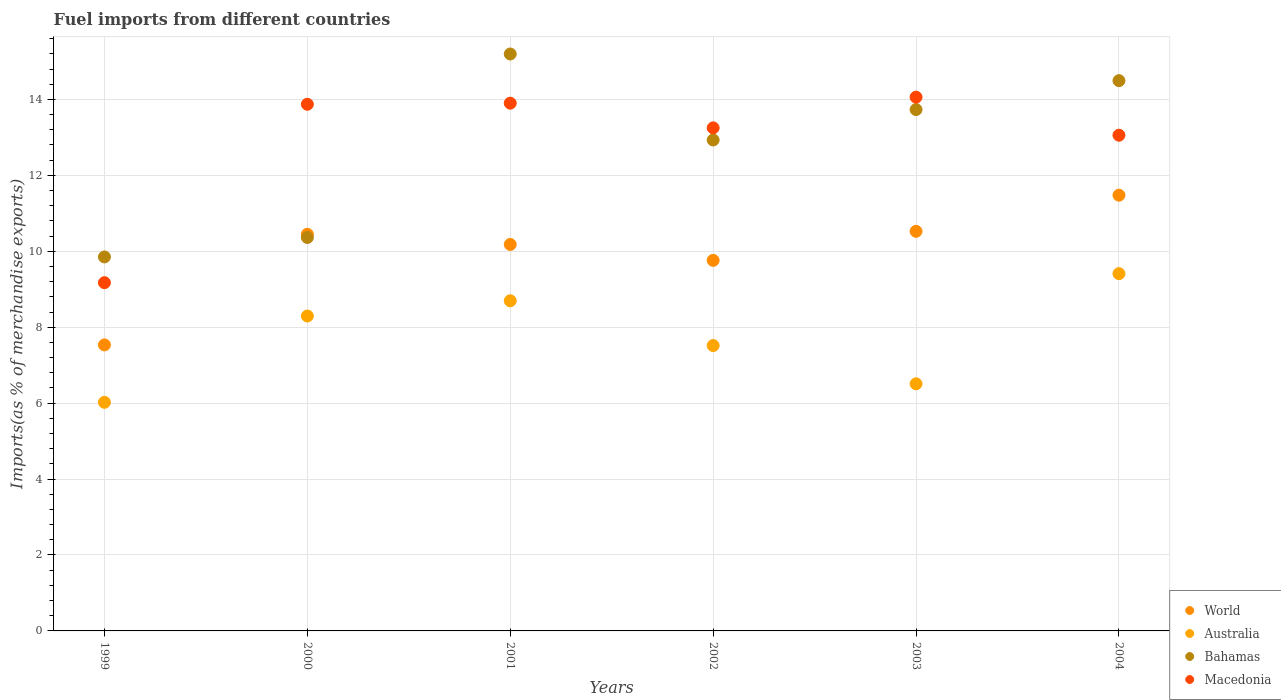How many different coloured dotlines are there?
Provide a succinct answer. 4. What is the percentage of imports to different countries in World in 2002?
Your answer should be compact. 9.76. Across all years, what is the maximum percentage of imports to different countries in Macedonia?
Make the answer very short. 14.06. Across all years, what is the minimum percentage of imports to different countries in World?
Offer a terse response. 7.53. What is the total percentage of imports to different countries in World in the graph?
Offer a very short reply. 59.93. What is the difference between the percentage of imports to different countries in Australia in 2002 and that in 2004?
Your answer should be very brief. -1.89. What is the difference between the percentage of imports to different countries in Bahamas in 2002 and the percentage of imports to different countries in Macedonia in 2003?
Offer a very short reply. -1.13. What is the average percentage of imports to different countries in Macedonia per year?
Ensure brevity in your answer.  12.89. In the year 2001, what is the difference between the percentage of imports to different countries in Australia and percentage of imports to different countries in Bahamas?
Ensure brevity in your answer.  -6.5. In how many years, is the percentage of imports to different countries in Macedonia greater than 1.6 %?
Your response must be concise. 6. What is the ratio of the percentage of imports to different countries in Australia in 1999 to that in 2002?
Provide a succinct answer. 0.8. Is the percentage of imports to different countries in Australia in 2001 less than that in 2003?
Give a very brief answer. No. Is the difference between the percentage of imports to different countries in Australia in 2003 and 2004 greater than the difference between the percentage of imports to different countries in Bahamas in 2003 and 2004?
Ensure brevity in your answer.  No. What is the difference between the highest and the second highest percentage of imports to different countries in World?
Offer a very short reply. 0.95. What is the difference between the highest and the lowest percentage of imports to different countries in Bahamas?
Offer a very short reply. 5.35. Does the percentage of imports to different countries in Bahamas monotonically increase over the years?
Provide a short and direct response. No. How many dotlines are there?
Offer a very short reply. 4. How many years are there in the graph?
Offer a terse response. 6. Are the values on the major ticks of Y-axis written in scientific E-notation?
Keep it short and to the point. No. Where does the legend appear in the graph?
Your answer should be compact. Bottom right. How many legend labels are there?
Provide a succinct answer. 4. How are the legend labels stacked?
Make the answer very short. Vertical. What is the title of the graph?
Ensure brevity in your answer.  Fuel imports from different countries. Does "Arab World" appear as one of the legend labels in the graph?
Make the answer very short. No. What is the label or title of the Y-axis?
Give a very brief answer. Imports(as % of merchandise exports). What is the Imports(as % of merchandise exports) in World in 1999?
Your answer should be very brief. 7.53. What is the Imports(as % of merchandise exports) in Australia in 1999?
Keep it short and to the point. 6.02. What is the Imports(as % of merchandise exports) of Bahamas in 1999?
Make the answer very short. 9.85. What is the Imports(as % of merchandise exports) of Macedonia in 1999?
Your response must be concise. 9.17. What is the Imports(as % of merchandise exports) of World in 2000?
Offer a very short reply. 10.45. What is the Imports(as % of merchandise exports) in Australia in 2000?
Offer a very short reply. 8.29. What is the Imports(as % of merchandise exports) in Bahamas in 2000?
Make the answer very short. 10.36. What is the Imports(as % of merchandise exports) of Macedonia in 2000?
Your answer should be compact. 13.87. What is the Imports(as % of merchandise exports) in World in 2001?
Provide a succinct answer. 10.18. What is the Imports(as % of merchandise exports) of Australia in 2001?
Provide a short and direct response. 8.7. What is the Imports(as % of merchandise exports) of Bahamas in 2001?
Your answer should be compact. 15.2. What is the Imports(as % of merchandise exports) in Macedonia in 2001?
Keep it short and to the point. 13.9. What is the Imports(as % of merchandise exports) of World in 2002?
Provide a short and direct response. 9.76. What is the Imports(as % of merchandise exports) of Australia in 2002?
Keep it short and to the point. 7.52. What is the Imports(as % of merchandise exports) in Bahamas in 2002?
Offer a terse response. 12.93. What is the Imports(as % of merchandise exports) of Macedonia in 2002?
Your answer should be compact. 13.25. What is the Imports(as % of merchandise exports) of World in 2003?
Ensure brevity in your answer.  10.53. What is the Imports(as % of merchandise exports) in Australia in 2003?
Offer a very short reply. 6.51. What is the Imports(as % of merchandise exports) of Bahamas in 2003?
Offer a very short reply. 13.73. What is the Imports(as % of merchandise exports) of Macedonia in 2003?
Offer a terse response. 14.06. What is the Imports(as % of merchandise exports) of World in 2004?
Provide a succinct answer. 11.48. What is the Imports(as % of merchandise exports) in Australia in 2004?
Give a very brief answer. 9.41. What is the Imports(as % of merchandise exports) in Bahamas in 2004?
Your answer should be very brief. 14.49. What is the Imports(as % of merchandise exports) of Macedonia in 2004?
Keep it short and to the point. 13.06. Across all years, what is the maximum Imports(as % of merchandise exports) of World?
Give a very brief answer. 11.48. Across all years, what is the maximum Imports(as % of merchandise exports) in Australia?
Offer a terse response. 9.41. Across all years, what is the maximum Imports(as % of merchandise exports) in Bahamas?
Offer a terse response. 15.2. Across all years, what is the maximum Imports(as % of merchandise exports) in Macedonia?
Your answer should be very brief. 14.06. Across all years, what is the minimum Imports(as % of merchandise exports) of World?
Your answer should be very brief. 7.53. Across all years, what is the minimum Imports(as % of merchandise exports) of Australia?
Give a very brief answer. 6.02. Across all years, what is the minimum Imports(as % of merchandise exports) in Bahamas?
Offer a very short reply. 9.85. Across all years, what is the minimum Imports(as % of merchandise exports) of Macedonia?
Offer a very short reply. 9.17. What is the total Imports(as % of merchandise exports) of World in the graph?
Make the answer very short. 59.93. What is the total Imports(as % of merchandise exports) in Australia in the graph?
Your response must be concise. 46.45. What is the total Imports(as % of merchandise exports) of Bahamas in the graph?
Give a very brief answer. 76.57. What is the total Imports(as % of merchandise exports) of Macedonia in the graph?
Your answer should be very brief. 77.31. What is the difference between the Imports(as % of merchandise exports) in World in 1999 and that in 2000?
Ensure brevity in your answer.  -2.91. What is the difference between the Imports(as % of merchandise exports) in Australia in 1999 and that in 2000?
Provide a short and direct response. -2.27. What is the difference between the Imports(as % of merchandise exports) in Bahamas in 1999 and that in 2000?
Ensure brevity in your answer.  -0.51. What is the difference between the Imports(as % of merchandise exports) in Macedonia in 1999 and that in 2000?
Give a very brief answer. -4.7. What is the difference between the Imports(as % of merchandise exports) of World in 1999 and that in 2001?
Give a very brief answer. -2.65. What is the difference between the Imports(as % of merchandise exports) of Australia in 1999 and that in 2001?
Ensure brevity in your answer.  -2.67. What is the difference between the Imports(as % of merchandise exports) of Bahamas in 1999 and that in 2001?
Your response must be concise. -5.35. What is the difference between the Imports(as % of merchandise exports) in Macedonia in 1999 and that in 2001?
Give a very brief answer. -4.73. What is the difference between the Imports(as % of merchandise exports) of World in 1999 and that in 2002?
Offer a terse response. -2.23. What is the difference between the Imports(as % of merchandise exports) in Australia in 1999 and that in 2002?
Your answer should be very brief. -1.49. What is the difference between the Imports(as % of merchandise exports) in Bahamas in 1999 and that in 2002?
Your answer should be compact. -3.08. What is the difference between the Imports(as % of merchandise exports) in Macedonia in 1999 and that in 2002?
Your answer should be compact. -4.08. What is the difference between the Imports(as % of merchandise exports) in World in 1999 and that in 2003?
Provide a succinct answer. -2.99. What is the difference between the Imports(as % of merchandise exports) of Australia in 1999 and that in 2003?
Provide a short and direct response. -0.49. What is the difference between the Imports(as % of merchandise exports) in Bahamas in 1999 and that in 2003?
Your answer should be compact. -3.88. What is the difference between the Imports(as % of merchandise exports) of Macedonia in 1999 and that in 2003?
Offer a very short reply. -4.89. What is the difference between the Imports(as % of merchandise exports) of World in 1999 and that in 2004?
Ensure brevity in your answer.  -3.94. What is the difference between the Imports(as % of merchandise exports) in Australia in 1999 and that in 2004?
Offer a very short reply. -3.39. What is the difference between the Imports(as % of merchandise exports) of Bahamas in 1999 and that in 2004?
Provide a short and direct response. -4.64. What is the difference between the Imports(as % of merchandise exports) in Macedonia in 1999 and that in 2004?
Give a very brief answer. -3.88. What is the difference between the Imports(as % of merchandise exports) in World in 2000 and that in 2001?
Make the answer very short. 0.27. What is the difference between the Imports(as % of merchandise exports) of Australia in 2000 and that in 2001?
Your answer should be very brief. -0.4. What is the difference between the Imports(as % of merchandise exports) of Bahamas in 2000 and that in 2001?
Your response must be concise. -4.83. What is the difference between the Imports(as % of merchandise exports) of Macedonia in 2000 and that in 2001?
Make the answer very short. -0.03. What is the difference between the Imports(as % of merchandise exports) in World in 2000 and that in 2002?
Provide a short and direct response. 0.69. What is the difference between the Imports(as % of merchandise exports) in Australia in 2000 and that in 2002?
Offer a terse response. 0.78. What is the difference between the Imports(as % of merchandise exports) in Bahamas in 2000 and that in 2002?
Ensure brevity in your answer.  -2.57. What is the difference between the Imports(as % of merchandise exports) in Macedonia in 2000 and that in 2002?
Ensure brevity in your answer.  0.62. What is the difference between the Imports(as % of merchandise exports) in World in 2000 and that in 2003?
Give a very brief answer. -0.08. What is the difference between the Imports(as % of merchandise exports) of Australia in 2000 and that in 2003?
Keep it short and to the point. 1.79. What is the difference between the Imports(as % of merchandise exports) of Bahamas in 2000 and that in 2003?
Make the answer very short. -3.37. What is the difference between the Imports(as % of merchandise exports) of Macedonia in 2000 and that in 2003?
Give a very brief answer. -0.19. What is the difference between the Imports(as % of merchandise exports) of World in 2000 and that in 2004?
Offer a very short reply. -1.03. What is the difference between the Imports(as % of merchandise exports) in Australia in 2000 and that in 2004?
Give a very brief answer. -1.12. What is the difference between the Imports(as % of merchandise exports) in Bahamas in 2000 and that in 2004?
Ensure brevity in your answer.  -4.13. What is the difference between the Imports(as % of merchandise exports) of Macedonia in 2000 and that in 2004?
Your answer should be compact. 0.81. What is the difference between the Imports(as % of merchandise exports) of World in 2001 and that in 2002?
Keep it short and to the point. 0.42. What is the difference between the Imports(as % of merchandise exports) of Australia in 2001 and that in 2002?
Provide a succinct answer. 1.18. What is the difference between the Imports(as % of merchandise exports) of Bahamas in 2001 and that in 2002?
Your answer should be very brief. 2.27. What is the difference between the Imports(as % of merchandise exports) in Macedonia in 2001 and that in 2002?
Your answer should be very brief. 0.65. What is the difference between the Imports(as % of merchandise exports) in World in 2001 and that in 2003?
Your answer should be very brief. -0.35. What is the difference between the Imports(as % of merchandise exports) of Australia in 2001 and that in 2003?
Your answer should be compact. 2.19. What is the difference between the Imports(as % of merchandise exports) of Bahamas in 2001 and that in 2003?
Your answer should be very brief. 1.46. What is the difference between the Imports(as % of merchandise exports) in Macedonia in 2001 and that in 2003?
Ensure brevity in your answer.  -0.16. What is the difference between the Imports(as % of merchandise exports) in World in 2001 and that in 2004?
Offer a very short reply. -1.3. What is the difference between the Imports(as % of merchandise exports) in Australia in 2001 and that in 2004?
Give a very brief answer. -0.71. What is the difference between the Imports(as % of merchandise exports) in Bahamas in 2001 and that in 2004?
Provide a succinct answer. 0.7. What is the difference between the Imports(as % of merchandise exports) of Macedonia in 2001 and that in 2004?
Your answer should be compact. 0.84. What is the difference between the Imports(as % of merchandise exports) of World in 2002 and that in 2003?
Make the answer very short. -0.77. What is the difference between the Imports(as % of merchandise exports) of Australia in 2002 and that in 2003?
Ensure brevity in your answer.  1.01. What is the difference between the Imports(as % of merchandise exports) of Bahamas in 2002 and that in 2003?
Ensure brevity in your answer.  -0.8. What is the difference between the Imports(as % of merchandise exports) of Macedonia in 2002 and that in 2003?
Your response must be concise. -0.81. What is the difference between the Imports(as % of merchandise exports) of World in 2002 and that in 2004?
Ensure brevity in your answer.  -1.72. What is the difference between the Imports(as % of merchandise exports) in Australia in 2002 and that in 2004?
Provide a short and direct response. -1.89. What is the difference between the Imports(as % of merchandise exports) in Bahamas in 2002 and that in 2004?
Your response must be concise. -1.56. What is the difference between the Imports(as % of merchandise exports) in Macedonia in 2002 and that in 2004?
Your answer should be compact. 0.19. What is the difference between the Imports(as % of merchandise exports) in World in 2003 and that in 2004?
Provide a short and direct response. -0.95. What is the difference between the Imports(as % of merchandise exports) of Australia in 2003 and that in 2004?
Ensure brevity in your answer.  -2.9. What is the difference between the Imports(as % of merchandise exports) in Bahamas in 2003 and that in 2004?
Offer a very short reply. -0.76. What is the difference between the Imports(as % of merchandise exports) in World in 1999 and the Imports(as % of merchandise exports) in Australia in 2000?
Give a very brief answer. -0.76. What is the difference between the Imports(as % of merchandise exports) of World in 1999 and the Imports(as % of merchandise exports) of Bahamas in 2000?
Keep it short and to the point. -2.83. What is the difference between the Imports(as % of merchandise exports) of World in 1999 and the Imports(as % of merchandise exports) of Macedonia in 2000?
Your answer should be compact. -6.34. What is the difference between the Imports(as % of merchandise exports) in Australia in 1999 and the Imports(as % of merchandise exports) in Bahamas in 2000?
Make the answer very short. -4.34. What is the difference between the Imports(as % of merchandise exports) of Australia in 1999 and the Imports(as % of merchandise exports) of Macedonia in 2000?
Offer a very short reply. -7.85. What is the difference between the Imports(as % of merchandise exports) of Bahamas in 1999 and the Imports(as % of merchandise exports) of Macedonia in 2000?
Your answer should be compact. -4.02. What is the difference between the Imports(as % of merchandise exports) in World in 1999 and the Imports(as % of merchandise exports) in Australia in 2001?
Offer a very short reply. -1.16. What is the difference between the Imports(as % of merchandise exports) in World in 1999 and the Imports(as % of merchandise exports) in Bahamas in 2001?
Provide a short and direct response. -7.66. What is the difference between the Imports(as % of merchandise exports) in World in 1999 and the Imports(as % of merchandise exports) in Macedonia in 2001?
Your answer should be compact. -6.37. What is the difference between the Imports(as % of merchandise exports) in Australia in 1999 and the Imports(as % of merchandise exports) in Bahamas in 2001?
Your answer should be very brief. -9.17. What is the difference between the Imports(as % of merchandise exports) in Australia in 1999 and the Imports(as % of merchandise exports) in Macedonia in 2001?
Keep it short and to the point. -7.88. What is the difference between the Imports(as % of merchandise exports) in Bahamas in 1999 and the Imports(as % of merchandise exports) in Macedonia in 2001?
Your answer should be compact. -4.05. What is the difference between the Imports(as % of merchandise exports) of World in 1999 and the Imports(as % of merchandise exports) of Australia in 2002?
Give a very brief answer. 0.02. What is the difference between the Imports(as % of merchandise exports) of World in 1999 and the Imports(as % of merchandise exports) of Bahamas in 2002?
Your answer should be very brief. -5.4. What is the difference between the Imports(as % of merchandise exports) of World in 1999 and the Imports(as % of merchandise exports) of Macedonia in 2002?
Your answer should be very brief. -5.72. What is the difference between the Imports(as % of merchandise exports) in Australia in 1999 and the Imports(as % of merchandise exports) in Bahamas in 2002?
Offer a terse response. -6.91. What is the difference between the Imports(as % of merchandise exports) in Australia in 1999 and the Imports(as % of merchandise exports) in Macedonia in 2002?
Provide a short and direct response. -7.23. What is the difference between the Imports(as % of merchandise exports) in Bahamas in 1999 and the Imports(as % of merchandise exports) in Macedonia in 2002?
Ensure brevity in your answer.  -3.4. What is the difference between the Imports(as % of merchandise exports) of World in 1999 and the Imports(as % of merchandise exports) of Australia in 2003?
Provide a succinct answer. 1.03. What is the difference between the Imports(as % of merchandise exports) in World in 1999 and the Imports(as % of merchandise exports) in Bahamas in 2003?
Offer a terse response. -6.2. What is the difference between the Imports(as % of merchandise exports) of World in 1999 and the Imports(as % of merchandise exports) of Macedonia in 2003?
Provide a short and direct response. -6.53. What is the difference between the Imports(as % of merchandise exports) of Australia in 1999 and the Imports(as % of merchandise exports) of Bahamas in 2003?
Provide a short and direct response. -7.71. What is the difference between the Imports(as % of merchandise exports) of Australia in 1999 and the Imports(as % of merchandise exports) of Macedonia in 2003?
Keep it short and to the point. -8.04. What is the difference between the Imports(as % of merchandise exports) of Bahamas in 1999 and the Imports(as % of merchandise exports) of Macedonia in 2003?
Provide a short and direct response. -4.21. What is the difference between the Imports(as % of merchandise exports) of World in 1999 and the Imports(as % of merchandise exports) of Australia in 2004?
Provide a succinct answer. -1.88. What is the difference between the Imports(as % of merchandise exports) in World in 1999 and the Imports(as % of merchandise exports) in Bahamas in 2004?
Give a very brief answer. -6.96. What is the difference between the Imports(as % of merchandise exports) of World in 1999 and the Imports(as % of merchandise exports) of Macedonia in 2004?
Offer a terse response. -5.52. What is the difference between the Imports(as % of merchandise exports) of Australia in 1999 and the Imports(as % of merchandise exports) of Bahamas in 2004?
Your answer should be compact. -8.47. What is the difference between the Imports(as % of merchandise exports) in Australia in 1999 and the Imports(as % of merchandise exports) in Macedonia in 2004?
Offer a terse response. -7.04. What is the difference between the Imports(as % of merchandise exports) of Bahamas in 1999 and the Imports(as % of merchandise exports) of Macedonia in 2004?
Provide a succinct answer. -3.21. What is the difference between the Imports(as % of merchandise exports) in World in 2000 and the Imports(as % of merchandise exports) in Australia in 2001?
Provide a short and direct response. 1.75. What is the difference between the Imports(as % of merchandise exports) in World in 2000 and the Imports(as % of merchandise exports) in Bahamas in 2001?
Provide a short and direct response. -4.75. What is the difference between the Imports(as % of merchandise exports) in World in 2000 and the Imports(as % of merchandise exports) in Macedonia in 2001?
Give a very brief answer. -3.45. What is the difference between the Imports(as % of merchandise exports) in Australia in 2000 and the Imports(as % of merchandise exports) in Bahamas in 2001?
Your answer should be compact. -6.9. What is the difference between the Imports(as % of merchandise exports) of Australia in 2000 and the Imports(as % of merchandise exports) of Macedonia in 2001?
Keep it short and to the point. -5.61. What is the difference between the Imports(as % of merchandise exports) in Bahamas in 2000 and the Imports(as % of merchandise exports) in Macedonia in 2001?
Ensure brevity in your answer.  -3.54. What is the difference between the Imports(as % of merchandise exports) of World in 2000 and the Imports(as % of merchandise exports) of Australia in 2002?
Ensure brevity in your answer.  2.93. What is the difference between the Imports(as % of merchandise exports) in World in 2000 and the Imports(as % of merchandise exports) in Bahamas in 2002?
Keep it short and to the point. -2.48. What is the difference between the Imports(as % of merchandise exports) in World in 2000 and the Imports(as % of merchandise exports) in Macedonia in 2002?
Offer a very short reply. -2.8. What is the difference between the Imports(as % of merchandise exports) of Australia in 2000 and the Imports(as % of merchandise exports) of Bahamas in 2002?
Make the answer very short. -4.64. What is the difference between the Imports(as % of merchandise exports) of Australia in 2000 and the Imports(as % of merchandise exports) of Macedonia in 2002?
Offer a very short reply. -4.96. What is the difference between the Imports(as % of merchandise exports) of Bahamas in 2000 and the Imports(as % of merchandise exports) of Macedonia in 2002?
Your answer should be compact. -2.89. What is the difference between the Imports(as % of merchandise exports) in World in 2000 and the Imports(as % of merchandise exports) in Australia in 2003?
Keep it short and to the point. 3.94. What is the difference between the Imports(as % of merchandise exports) of World in 2000 and the Imports(as % of merchandise exports) of Bahamas in 2003?
Make the answer very short. -3.28. What is the difference between the Imports(as % of merchandise exports) in World in 2000 and the Imports(as % of merchandise exports) in Macedonia in 2003?
Offer a terse response. -3.61. What is the difference between the Imports(as % of merchandise exports) in Australia in 2000 and the Imports(as % of merchandise exports) in Bahamas in 2003?
Give a very brief answer. -5.44. What is the difference between the Imports(as % of merchandise exports) of Australia in 2000 and the Imports(as % of merchandise exports) of Macedonia in 2003?
Offer a very short reply. -5.77. What is the difference between the Imports(as % of merchandise exports) in Bahamas in 2000 and the Imports(as % of merchandise exports) in Macedonia in 2003?
Offer a terse response. -3.7. What is the difference between the Imports(as % of merchandise exports) in World in 2000 and the Imports(as % of merchandise exports) in Australia in 2004?
Give a very brief answer. 1.04. What is the difference between the Imports(as % of merchandise exports) of World in 2000 and the Imports(as % of merchandise exports) of Bahamas in 2004?
Give a very brief answer. -4.05. What is the difference between the Imports(as % of merchandise exports) in World in 2000 and the Imports(as % of merchandise exports) in Macedonia in 2004?
Give a very brief answer. -2.61. What is the difference between the Imports(as % of merchandise exports) of Australia in 2000 and the Imports(as % of merchandise exports) of Bahamas in 2004?
Offer a terse response. -6.2. What is the difference between the Imports(as % of merchandise exports) of Australia in 2000 and the Imports(as % of merchandise exports) of Macedonia in 2004?
Your answer should be very brief. -4.76. What is the difference between the Imports(as % of merchandise exports) of Bahamas in 2000 and the Imports(as % of merchandise exports) of Macedonia in 2004?
Your answer should be very brief. -2.69. What is the difference between the Imports(as % of merchandise exports) of World in 2001 and the Imports(as % of merchandise exports) of Australia in 2002?
Make the answer very short. 2.66. What is the difference between the Imports(as % of merchandise exports) in World in 2001 and the Imports(as % of merchandise exports) in Bahamas in 2002?
Keep it short and to the point. -2.75. What is the difference between the Imports(as % of merchandise exports) of World in 2001 and the Imports(as % of merchandise exports) of Macedonia in 2002?
Ensure brevity in your answer.  -3.07. What is the difference between the Imports(as % of merchandise exports) in Australia in 2001 and the Imports(as % of merchandise exports) in Bahamas in 2002?
Keep it short and to the point. -4.24. What is the difference between the Imports(as % of merchandise exports) of Australia in 2001 and the Imports(as % of merchandise exports) of Macedonia in 2002?
Your answer should be compact. -4.55. What is the difference between the Imports(as % of merchandise exports) in Bahamas in 2001 and the Imports(as % of merchandise exports) in Macedonia in 2002?
Ensure brevity in your answer.  1.95. What is the difference between the Imports(as % of merchandise exports) of World in 2001 and the Imports(as % of merchandise exports) of Australia in 2003?
Your answer should be very brief. 3.67. What is the difference between the Imports(as % of merchandise exports) of World in 2001 and the Imports(as % of merchandise exports) of Bahamas in 2003?
Offer a terse response. -3.55. What is the difference between the Imports(as % of merchandise exports) of World in 2001 and the Imports(as % of merchandise exports) of Macedonia in 2003?
Keep it short and to the point. -3.88. What is the difference between the Imports(as % of merchandise exports) of Australia in 2001 and the Imports(as % of merchandise exports) of Bahamas in 2003?
Offer a terse response. -5.04. What is the difference between the Imports(as % of merchandise exports) in Australia in 2001 and the Imports(as % of merchandise exports) in Macedonia in 2003?
Offer a terse response. -5.36. What is the difference between the Imports(as % of merchandise exports) of Bahamas in 2001 and the Imports(as % of merchandise exports) of Macedonia in 2003?
Keep it short and to the point. 1.14. What is the difference between the Imports(as % of merchandise exports) of World in 2001 and the Imports(as % of merchandise exports) of Australia in 2004?
Offer a terse response. 0.77. What is the difference between the Imports(as % of merchandise exports) of World in 2001 and the Imports(as % of merchandise exports) of Bahamas in 2004?
Your response must be concise. -4.31. What is the difference between the Imports(as % of merchandise exports) in World in 2001 and the Imports(as % of merchandise exports) in Macedonia in 2004?
Offer a terse response. -2.88. What is the difference between the Imports(as % of merchandise exports) of Australia in 2001 and the Imports(as % of merchandise exports) of Bahamas in 2004?
Provide a succinct answer. -5.8. What is the difference between the Imports(as % of merchandise exports) of Australia in 2001 and the Imports(as % of merchandise exports) of Macedonia in 2004?
Your answer should be very brief. -4.36. What is the difference between the Imports(as % of merchandise exports) in Bahamas in 2001 and the Imports(as % of merchandise exports) in Macedonia in 2004?
Provide a short and direct response. 2.14. What is the difference between the Imports(as % of merchandise exports) of World in 2002 and the Imports(as % of merchandise exports) of Australia in 2003?
Offer a very short reply. 3.25. What is the difference between the Imports(as % of merchandise exports) in World in 2002 and the Imports(as % of merchandise exports) in Bahamas in 2003?
Ensure brevity in your answer.  -3.97. What is the difference between the Imports(as % of merchandise exports) of World in 2002 and the Imports(as % of merchandise exports) of Macedonia in 2003?
Your response must be concise. -4.3. What is the difference between the Imports(as % of merchandise exports) in Australia in 2002 and the Imports(as % of merchandise exports) in Bahamas in 2003?
Provide a short and direct response. -6.22. What is the difference between the Imports(as % of merchandise exports) in Australia in 2002 and the Imports(as % of merchandise exports) in Macedonia in 2003?
Your answer should be compact. -6.54. What is the difference between the Imports(as % of merchandise exports) of Bahamas in 2002 and the Imports(as % of merchandise exports) of Macedonia in 2003?
Offer a terse response. -1.13. What is the difference between the Imports(as % of merchandise exports) of World in 2002 and the Imports(as % of merchandise exports) of Australia in 2004?
Your response must be concise. 0.35. What is the difference between the Imports(as % of merchandise exports) of World in 2002 and the Imports(as % of merchandise exports) of Bahamas in 2004?
Your response must be concise. -4.73. What is the difference between the Imports(as % of merchandise exports) of World in 2002 and the Imports(as % of merchandise exports) of Macedonia in 2004?
Ensure brevity in your answer.  -3.3. What is the difference between the Imports(as % of merchandise exports) in Australia in 2002 and the Imports(as % of merchandise exports) in Bahamas in 2004?
Provide a short and direct response. -6.98. What is the difference between the Imports(as % of merchandise exports) in Australia in 2002 and the Imports(as % of merchandise exports) in Macedonia in 2004?
Keep it short and to the point. -5.54. What is the difference between the Imports(as % of merchandise exports) of Bahamas in 2002 and the Imports(as % of merchandise exports) of Macedonia in 2004?
Offer a very short reply. -0.13. What is the difference between the Imports(as % of merchandise exports) of World in 2003 and the Imports(as % of merchandise exports) of Australia in 2004?
Your response must be concise. 1.12. What is the difference between the Imports(as % of merchandise exports) in World in 2003 and the Imports(as % of merchandise exports) in Bahamas in 2004?
Your response must be concise. -3.97. What is the difference between the Imports(as % of merchandise exports) in World in 2003 and the Imports(as % of merchandise exports) in Macedonia in 2004?
Your response must be concise. -2.53. What is the difference between the Imports(as % of merchandise exports) of Australia in 2003 and the Imports(as % of merchandise exports) of Bahamas in 2004?
Your answer should be very brief. -7.99. What is the difference between the Imports(as % of merchandise exports) in Australia in 2003 and the Imports(as % of merchandise exports) in Macedonia in 2004?
Keep it short and to the point. -6.55. What is the difference between the Imports(as % of merchandise exports) in Bahamas in 2003 and the Imports(as % of merchandise exports) in Macedonia in 2004?
Give a very brief answer. 0.68. What is the average Imports(as % of merchandise exports) in World per year?
Give a very brief answer. 9.99. What is the average Imports(as % of merchandise exports) of Australia per year?
Provide a succinct answer. 7.74. What is the average Imports(as % of merchandise exports) of Bahamas per year?
Ensure brevity in your answer.  12.76. What is the average Imports(as % of merchandise exports) in Macedonia per year?
Provide a succinct answer. 12.89. In the year 1999, what is the difference between the Imports(as % of merchandise exports) in World and Imports(as % of merchandise exports) in Australia?
Your answer should be very brief. 1.51. In the year 1999, what is the difference between the Imports(as % of merchandise exports) in World and Imports(as % of merchandise exports) in Bahamas?
Provide a succinct answer. -2.32. In the year 1999, what is the difference between the Imports(as % of merchandise exports) in World and Imports(as % of merchandise exports) in Macedonia?
Make the answer very short. -1.64. In the year 1999, what is the difference between the Imports(as % of merchandise exports) of Australia and Imports(as % of merchandise exports) of Bahamas?
Give a very brief answer. -3.83. In the year 1999, what is the difference between the Imports(as % of merchandise exports) of Australia and Imports(as % of merchandise exports) of Macedonia?
Offer a terse response. -3.15. In the year 1999, what is the difference between the Imports(as % of merchandise exports) of Bahamas and Imports(as % of merchandise exports) of Macedonia?
Provide a succinct answer. 0.68. In the year 2000, what is the difference between the Imports(as % of merchandise exports) in World and Imports(as % of merchandise exports) in Australia?
Keep it short and to the point. 2.15. In the year 2000, what is the difference between the Imports(as % of merchandise exports) in World and Imports(as % of merchandise exports) in Bahamas?
Provide a short and direct response. 0.09. In the year 2000, what is the difference between the Imports(as % of merchandise exports) in World and Imports(as % of merchandise exports) in Macedonia?
Provide a succinct answer. -3.42. In the year 2000, what is the difference between the Imports(as % of merchandise exports) in Australia and Imports(as % of merchandise exports) in Bahamas?
Offer a very short reply. -2.07. In the year 2000, what is the difference between the Imports(as % of merchandise exports) in Australia and Imports(as % of merchandise exports) in Macedonia?
Provide a short and direct response. -5.58. In the year 2000, what is the difference between the Imports(as % of merchandise exports) of Bahamas and Imports(as % of merchandise exports) of Macedonia?
Ensure brevity in your answer.  -3.51. In the year 2001, what is the difference between the Imports(as % of merchandise exports) of World and Imports(as % of merchandise exports) of Australia?
Offer a terse response. 1.48. In the year 2001, what is the difference between the Imports(as % of merchandise exports) of World and Imports(as % of merchandise exports) of Bahamas?
Offer a very short reply. -5.02. In the year 2001, what is the difference between the Imports(as % of merchandise exports) in World and Imports(as % of merchandise exports) in Macedonia?
Make the answer very short. -3.72. In the year 2001, what is the difference between the Imports(as % of merchandise exports) in Australia and Imports(as % of merchandise exports) in Bahamas?
Ensure brevity in your answer.  -6.5. In the year 2001, what is the difference between the Imports(as % of merchandise exports) in Australia and Imports(as % of merchandise exports) in Macedonia?
Your answer should be very brief. -5.21. In the year 2001, what is the difference between the Imports(as % of merchandise exports) of Bahamas and Imports(as % of merchandise exports) of Macedonia?
Keep it short and to the point. 1.3. In the year 2002, what is the difference between the Imports(as % of merchandise exports) in World and Imports(as % of merchandise exports) in Australia?
Keep it short and to the point. 2.24. In the year 2002, what is the difference between the Imports(as % of merchandise exports) in World and Imports(as % of merchandise exports) in Bahamas?
Ensure brevity in your answer.  -3.17. In the year 2002, what is the difference between the Imports(as % of merchandise exports) in World and Imports(as % of merchandise exports) in Macedonia?
Make the answer very short. -3.49. In the year 2002, what is the difference between the Imports(as % of merchandise exports) of Australia and Imports(as % of merchandise exports) of Bahamas?
Keep it short and to the point. -5.42. In the year 2002, what is the difference between the Imports(as % of merchandise exports) in Australia and Imports(as % of merchandise exports) in Macedonia?
Ensure brevity in your answer.  -5.73. In the year 2002, what is the difference between the Imports(as % of merchandise exports) in Bahamas and Imports(as % of merchandise exports) in Macedonia?
Ensure brevity in your answer.  -0.32. In the year 2003, what is the difference between the Imports(as % of merchandise exports) of World and Imports(as % of merchandise exports) of Australia?
Keep it short and to the point. 4.02. In the year 2003, what is the difference between the Imports(as % of merchandise exports) of World and Imports(as % of merchandise exports) of Bahamas?
Give a very brief answer. -3.21. In the year 2003, what is the difference between the Imports(as % of merchandise exports) of World and Imports(as % of merchandise exports) of Macedonia?
Keep it short and to the point. -3.53. In the year 2003, what is the difference between the Imports(as % of merchandise exports) in Australia and Imports(as % of merchandise exports) in Bahamas?
Your response must be concise. -7.22. In the year 2003, what is the difference between the Imports(as % of merchandise exports) in Australia and Imports(as % of merchandise exports) in Macedonia?
Your response must be concise. -7.55. In the year 2003, what is the difference between the Imports(as % of merchandise exports) in Bahamas and Imports(as % of merchandise exports) in Macedonia?
Make the answer very short. -0.33. In the year 2004, what is the difference between the Imports(as % of merchandise exports) of World and Imports(as % of merchandise exports) of Australia?
Your response must be concise. 2.07. In the year 2004, what is the difference between the Imports(as % of merchandise exports) of World and Imports(as % of merchandise exports) of Bahamas?
Your answer should be very brief. -3.02. In the year 2004, what is the difference between the Imports(as % of merchandise exports) of World and Imports(as % of merchandise exports) of Macedonia?
Offer a very short reply. -1.58. In the year 2004, what is the difference between the Imports(as % of merchandise exports) in Australia and Imports(as % of merchandise exports) in Bahamas?
Your answer should be compact. -5.08. In the year 2004, what is the difference between the Imports(as % of merchandise exports) in Australia and Imports(as % of merchandise exports) in Macedonia?
Provide a short and direct response. -3.65. In the year 2004, what is the difference between the Imports(as % of merchandise exports) of Bahamas and Imports(as % of merchandise exports) of Macedonia?
Give a very brief answer. 1.44. What is the ratio of the Imports(as % of merchandise exports) of World in 1999 to that in 2000?
Your answer should be very brief. 0.72. What is the ratio of the Imports(as % of merchandise exports) of Australia in 1999 to that in 2000?
Keep it short and to the point. 0.73. What is the ratio of the Imports(as % of merchandise exports) of Bahamas in 1999 to that in 2000?
Offer a terse response. 0.95. What is the ratio of the Imports(as % of merchandise exports) in Macedonia in 1999 to that in 2000?
Offer a terse response. 0.66. What is the ratio of the Imports(as % of merchandise exports) of World in 1999 to that in 2001?
Provide a short and direct response. 0.74. What is the ratio of the Imports(as % of merchandise exports) of Australia in 1999 to that in 2001?
Give a very brief answer. 0.69. What is the ratio of the Imports(as % of merchandise exports) in Bahamas in 1999 to that in 2001?
Make the answer very short. 0.65. What is the ratio of the Imports(as % of merchandise exports) of Macedonia in 1999 to that in 2001?
Give a very brief answer. 0.66. What is the ratio of the Imports(as % of merchandise exports) of World in 1999 to that in 2002?
Make the answer very short. 0.77. What is the ratio of the Imports(as % of merchandise exports) of Australia in 1999 to that in 2002?
Offer a very short reply. 0.8. What is the ratio of the Imports(as % of merchandise exports) of Bahamas in 1999 to that in 2002?
Your answer should be very brief. 0.76. What is the ratio of the Imports(as % of merchandise exports) in Macedonia in 1999 to that in 2002?
Your answer should be compact. 0.69. What is the ratio of the Imports(as % of merchandise exports) in World in 1999 to that in 2003?
Your response must be concise. 0.72. What is the ratio of the Imports(as % of merchandise exports) of Australia in 1999 to that in 2003?
Offer a very short reply. 0.93. What is the ratio of the Imports(as % of merchandise exports) of Bahamas in 1999 to that in 2003?
Give a very brief answer. 0.72. What is the ratio of the Imports(as % of merchandise exports) in Macedonia in 1999 to that in 2003?
Make the answer very short. 0.65. What is the ratio of the Imports(as % of merchandise exports) of World in 1999 to that in 2004?
Provide a short and direct response. 0.66. What is the ratio of the Imports(as % of merchandise exports) of Australia in 1999 to that in 2004?
Your answer should be very brief. 0.64. What is the ratio of the Imports(as % of merchandise exports) of Bahamas in 1999 to that in 2004?
Offer a very short reply. 0.68. What is the ratio of the Imports(as % of merchandise exports) in Macedonia in 1999 to that in 2004?
Provide a short and direct response. 0.7. What is the ratio of the Imports(as % of merchandise exports) in World in 2000 to that in 2001?
Provide a succinct answer. 1.03. What is the ratio of the Imports(as % of merchandise exports) in Australia in 2000 to that in 2001?
Give a very brief answer. 0.95. What is the ratio of the Imports(as % of merchandise exports) in Bahamas in 2000 to that in 2001?
Provide a succinct answer. 0.68. What is the ratio of the Imports(as % of merchandise exports) in Macedonia in 2000 to that in 2001?
Offer a very short reply. 1. What is the ratio of the Imports(as % of merchandise exports) of World in 2000 to that in 2002?
Provide a short and direct response. 1.07. What is the ratio of the Imports(as % of merchandise exports) in Australia in 2000 to that in 2002?
Offer a very short reply. 1.1. What is the ratio of the Imports(as % of merchandise exports) of Bahamas in 2000 to that in 2002?
Give a very brief answer. 0.8. What is the ratio of the Imports(as % of merchandise exports) in Macedonia in 2000 to that in 2002?
Your answer should be very brief. 1.05. What is the ratio of the Imports(as % of merchandise exports) of Australia in 2000 to that in 2003?
Provide a short and direct response. 1.27. What is the ratio of the Imports(as % of merchandise exports) in Bahamas in 2000 to that in 2003?
Provide a short and direct response. 0.75. What is the ratio of the Imports(as % of merchandise exports) in Macedonia in 2000 to that in 2003?
Your answer should be very brief. 0.99. What is the ratio of the Imports(as % of merchandise exports) of World in 2000 to that in 2004?
Provide a succinct answer. 0.91. What is the ratio of the Imports(as % of merchandise exports) in Australia in 2000 to that in 2004?
Provide a succinct answer. 0.88. What is the ratio of the Imports(as % of merchandise exports) of Bahamas in 2000 to that in 2004?
Give a very brief answer. 0.71. What is the ratio of the Imports(as % of merchandise exports) in Macedonia in 2000 to that in 2004?
Offer a terse response. 1.06. What is the ratio of the Imports(as % of merchandise exports) of World in 2001 to that in 2002?
Provide a short and direct response. 1.04. What is the ratio of the Imports(as % of merchandise exports) of Australia in 2001 to that in 2002?
Offer a terse response. 1.16. What is the ratio of the Imports(as % of merchandise exports) in Bahamas in 2001 to that in 2002?
Your response must be concise. 1.18. What is the ratio of the Imports(as % of merchandise exports) of Macedonia in 2001 to that in 2002?
Provide a short and direct response. 1.05. What is the ratio of the Imports(as % of merchandise exports) of World in 2001 to that in 2003?
Give a very brief answer. 0.97. What is the ratio of the Imports(as % of merchandise exports) of Australia in 2001 to that in 2003?
Provide a succinct answer. 1.34. What is the ratio of the Imports(as % of merchandise exports) in Bahamas in 2001 to that in 2003?
Make the answer very short. 1.11. What is the ratio of the Imports(as % of merchandise exports) in Macedonia in 2001 to that in 2003?
Ensure brevity in your answer.  0.99. What is the ratio of the Imports(as % of merchandise exports) of World in 2001 to that in 2004?
Offer a very short reply. 0.89. What is the ratio of the Imports(as % of merchandise exports) in Australia in 2001 to that in 2004?
Give a very brief answer. 0.92. What is the ratio of the Imports(as % of merchandise exports) of Bahamas in 2001 to that in 2004?
Keep it short and to the point. 1.05. What is the ratio of the Imports(as % of merchandise exports) in Macedonia in 2001 to that in 2004?
Give a very brief answer. 1.06. What is the ratio of the Imports(as % of merchandise exports) in World in 2002 to that in 2003?
Offer a very short reply. 0.93. What is the ratio of the Imports(as % of merchandise exports) of Australia in 2002 to that in 2003?
Provide a succinct answer. 1.15. What is the ratio of the Imports(as % of merchandise exports) of Bahamas in 2002 to that in 2003?
Offer a terse response. 0.94. What is the ratio of the Imports(as % of merchandise exports) of Macedonia in 2002 to that in 2003?
Ensure brevity in your answer.  0.94. What is the ratio of the Imports(as % of merchandise exports) in World in 2002 to that in 2004?
Provide a short and direct response. 0.85. What is the ratio of the Imports(as % of merchandise exports) in Australia in 2002 to that in 2004?
Your response must be concise. 0.8. What is the ratio of the Imports(as % of merchandise exports) of Bahamas in 2002 to that in 2004?
Give a very brief answer. 0.89. What is the ratio of the Imports(as % of merchandise exports) in Macedonia in 2002 to that in 2004?
Make the answer very short. 1.01. What is the ratio of the Imports(as % of merchandise exports) in World in 2003 to that in 2004?
Keep it short and to the point. 0.92. What is the ratio of the Imports(as % of merchandise exports) in Australia in 2003 to that in 2004?
Provide a short and direct response. 0.69. What is the ratio of the Imports(as % of merchandise exports) of Bahamas in 2003 to that in 2004?
Provide a succinct answer. 0.95. What is the ratio of the Imports(as % of merchandise exports) in Macedonia in 2003 to that in 2004?
Offer a very short reply. 1.08. What is the difference between the highest and the second highest Imports(as % of merchandise exports) in World?
Give a very brief answer. 0.95. What is the difference between the highest and the second highest Imports(as % of merchandise exports) of Australia?
Your response must be concise. 0.71. What is the difference between the highest and the second highest Imports(as % of merchandise exports) of Bahamas?
Provide a succinct answer. 0.7. What is the difference between the highest and the second highest Imports(as % of merchandise exports) of Macedonia?
Give a very brief answer. 0.16. What is the difference between the highest and the lowest Imports(as % of merchandise exports) of World?
Your answer should be very brief. 3.94. What is the difference between the highest and the lowest Imports(as % of merchandise exports) of Australia?
Offer a terse response. 3.39. What is the difference between the highest and the lowest Imports(as % of merchandise exports) of Bahamas?
Give a very brief answer. 5.35. What is the difference between the highest and the lowest Imports(as % of merchandise exports) in Macedonia?
Keep it short and to the point. 4.89. 